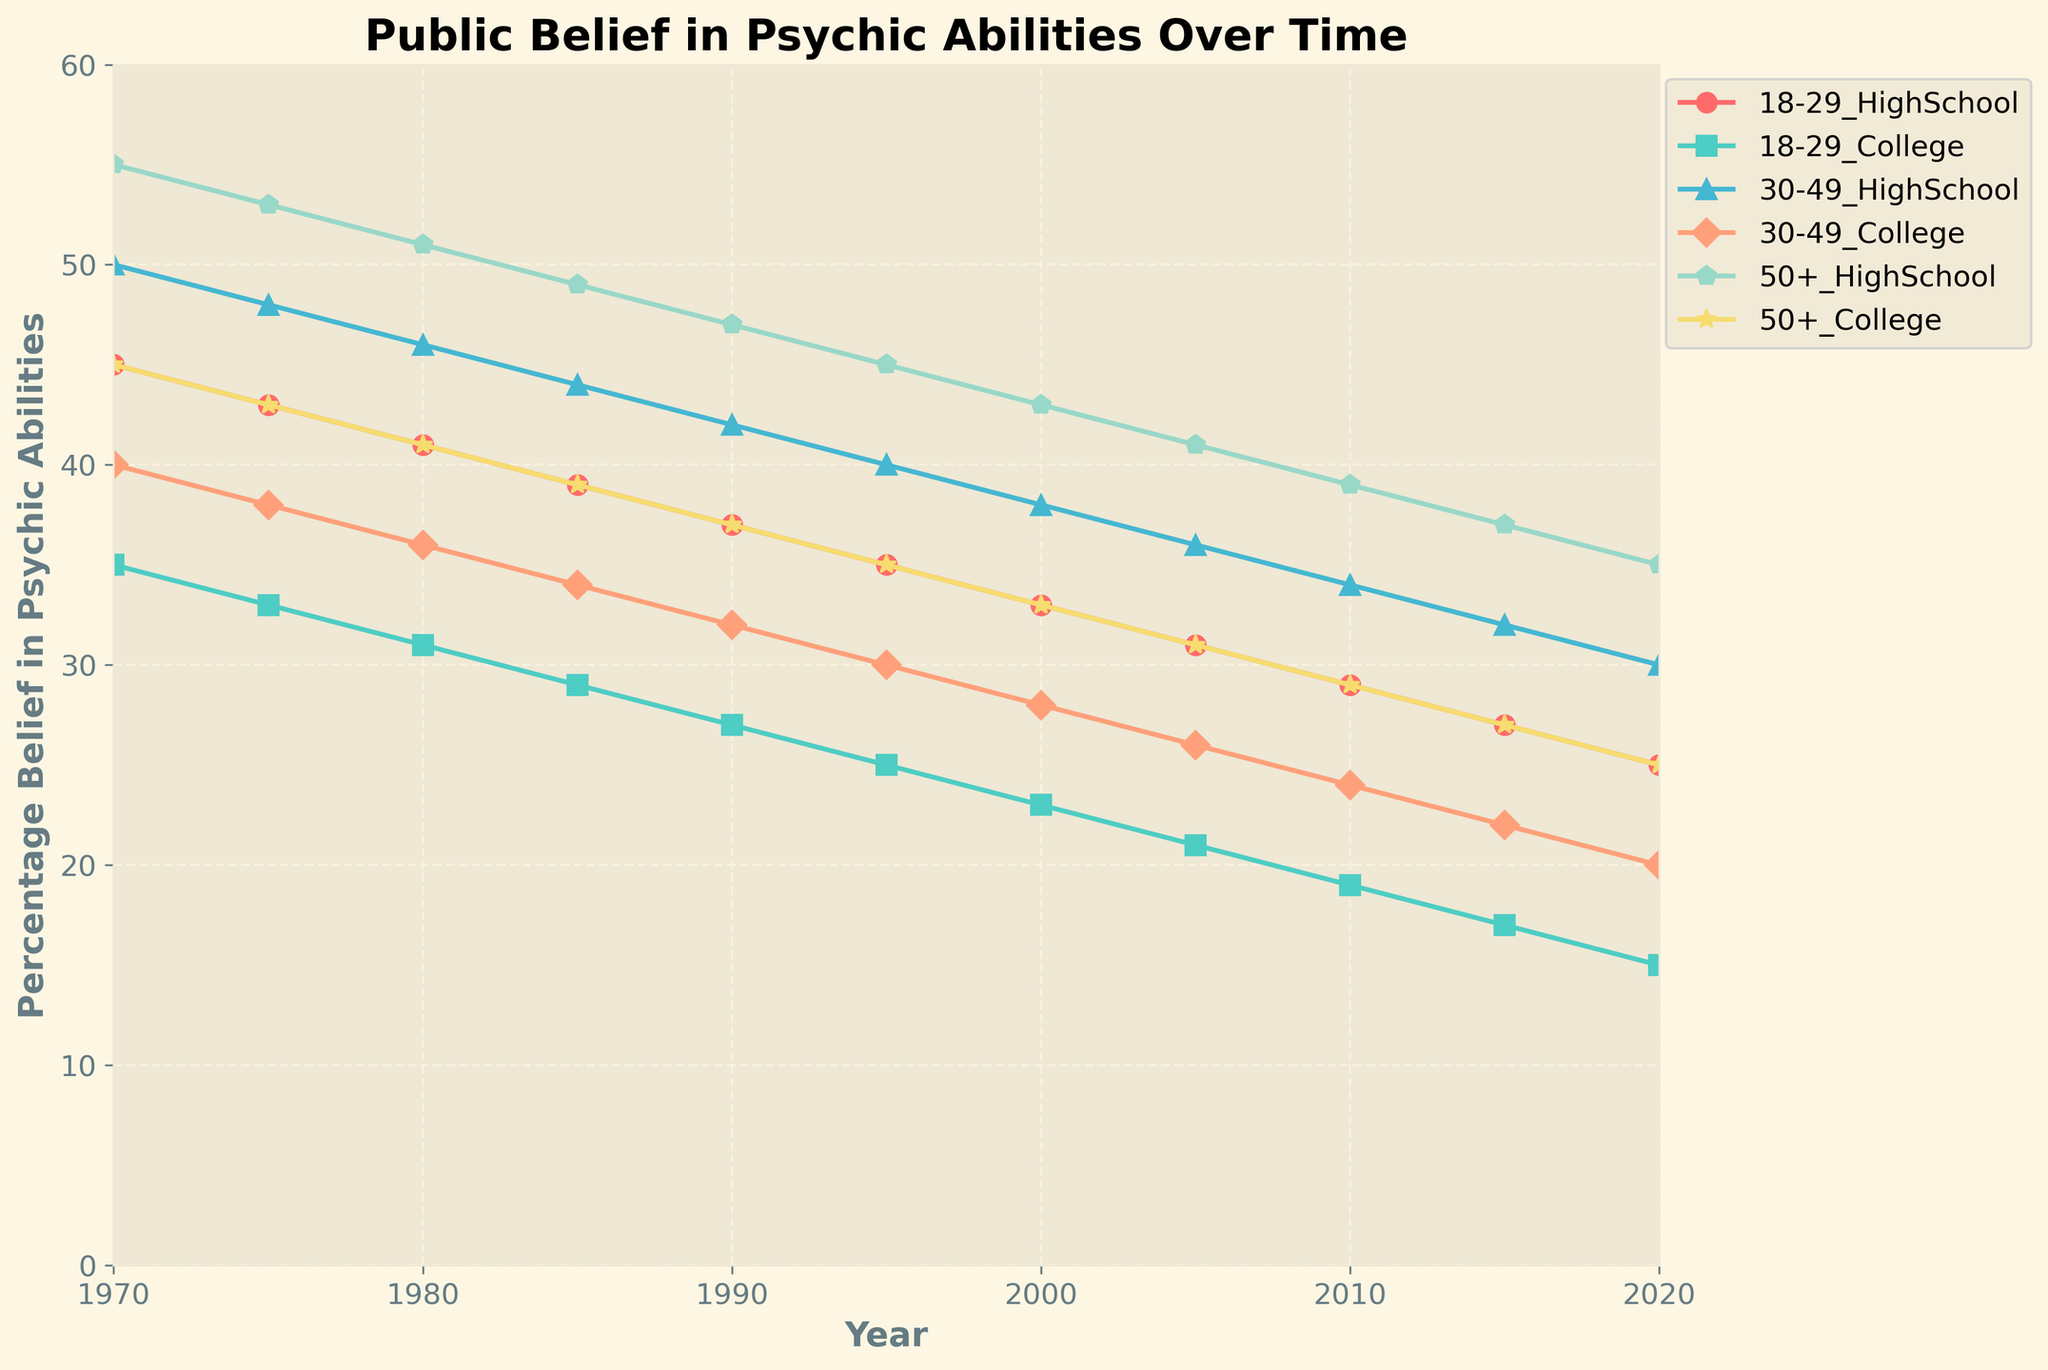What is the trend in belief in psychic abilities for the 50+ age group with only a high school education from 1970 to 2020? To identify the trend, look at the plotted line for the 50+ age group with a high school education. This line starts at 55% in 1970 and decreases steadily down to 35% by 2020. The steady decline indicates a general decrease in belief over time.
Answer: Decreasing Among the 18-29 age group, how does the belief differ between those with a high school education and those with a college education in 1970? Locate the points for 18-29 age group in 1970 on the chart. The belief percentages are 45% for high school graduates and 35% for college graduates. The difference is 45% - 35%.
Answer: 10% What age and education group had the highest belief in psychic abilities in 1970? Look at the starting points for all groups in 1970. The group aged 50+ with a high school education has the highest belief at 55%.
Answer: 50+ High School How has the belief in psychic abilities for the 30-49 age group with a college education changed from 1970 to 2020? Identify the plotted line for the 30-49 age group with a college education. In 1970, the belief is 40%, and in 2020, it is 20%. There is a decrease of 40% - 20%.
Answer: Decreased by 20% Is there a group where the belief in psychic abilities remained stable over the years? Analyze all the plotted lines for each group. None of the lines are flat; all show a declining trend over the years indicating a general decrease.
Answer: No Which age and education group shows the steepest decline in belief in psychic abilities from 1970 to 2020? Compare the slopes of the lines for all groups. The 50+ high school group declines from 55% to 35%, a 20% drop. The 18-29 high school group declines from 45% to 25%, also a 20% drop, but this is over a slightly smaller initial value. Thus, the steepest relative decline appears for 18-29 (high school).
Answer: 18-29 High School What was the percentage belief in psychic abilities for the 18-29 college group in 2010? Locate the point for the 18-29 college group in 2010. The percentage belief is 19%.
Answer: 19% Which group experienced the largest drop in belief in psychic abilities between 1980 and 1995? Calculate the drop for each group between 1980 and 1995 by finding the difference in values. The 50+ high school group drops from 51% to 45%, a 6% drop, which is the largest among the groups.
Answer: 50+ High School From the visual attributes of the lines, which group had the most consistent decline in belief over the years? Assess the smoothness and consistency of the trend lines. The 30-49 college group line appears the most consistently declining without abrupt changes.
Answer: 30-49 College 